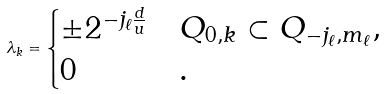Convert formula to latex. <formula><loc_0><loc_0><loc_500><loc_500>\lambda _ { k } = \begin{cases} \pm 2 ^ { - j _ { \ell } \frac { d } { u } } & Q _ { 0 , k } \subset Q _ { - j _ { \ell } , m _ { \ell } } , \\ 0 & . \end{cases}</formula> 